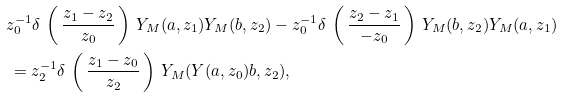Convert formula to latex. <formula><loc_0><loc_0><loc_500><loc_500>& z _ { 0 } ^ { - 1 } \delta \, \left ( \, \frac { z _ { 1 } - z _ { 2 } } { z _ { 0 } } \, \right ) \, Y _ { M } ( a , z _ { 1 } ) Y _ { M } ( b , z _ { 2 } ) - z _ { 0 } ^ { - 1 } \delta \, \left ( \, \frac { z _ { 2 } - z _ { 1 } } { - z _ { 0 } } \, \right ) \, Y _ { M } ( b , z _ { 2 } ) Y _ { M } ( a , z _ { 1 } ) \\ & \, = z _ { 2 } ^ { - 1 } \delta \, \left ( \, \frac { z _ { 1 } - z _ { 0 } } { z _ { 2 } } \, \right ) \, Y _ { M } ( Y ( a , z _ { 0 } ) b , z _ { 2 } ) ,</formula> 